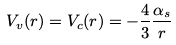<formula> <loc_0><loc_0><loc_500><loc_500>V _ { v } ( r ) = V _ { c } ( r ) = - \frac { 4 } { 3 } \frac { \alpha _ { s } } { r }</formula> 